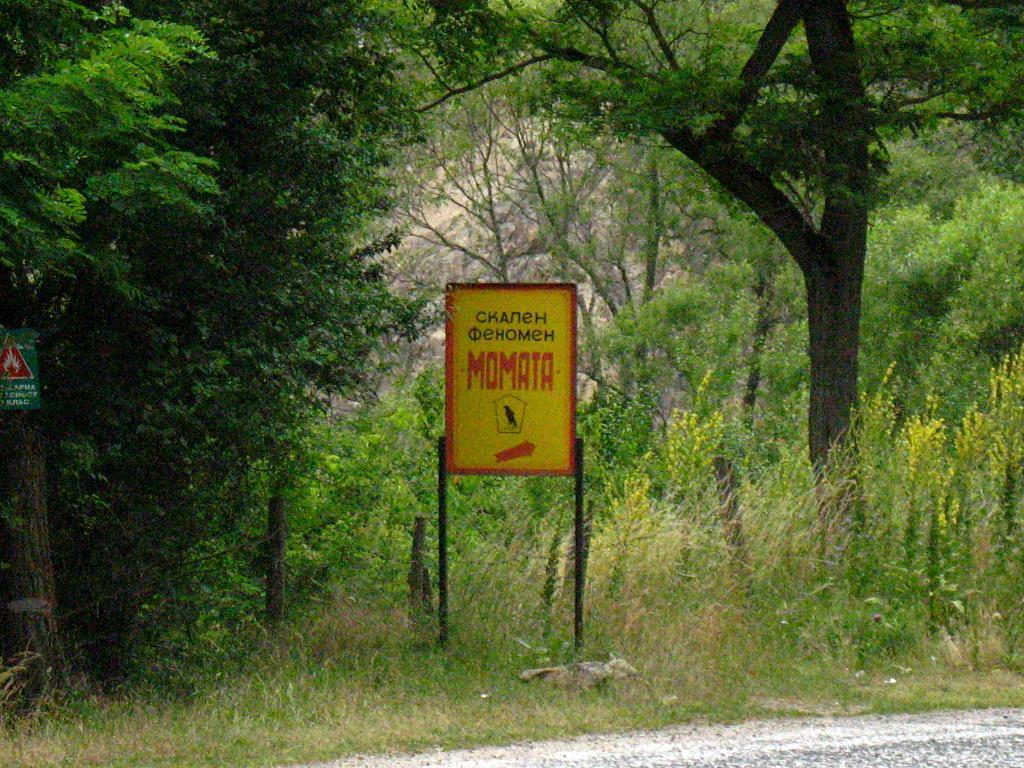Provide a one-sentence caption for the provided image. The sign for Momata is displayed in yellow and red colors. 